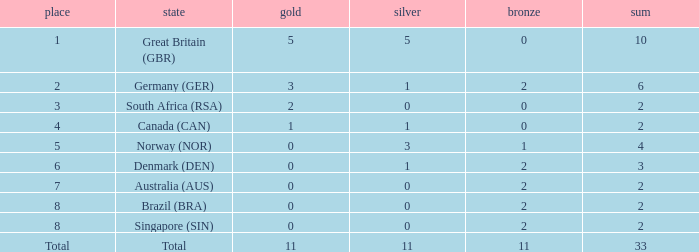What is the least total when the nation is canada (can) and bronze is less than 0? None. 